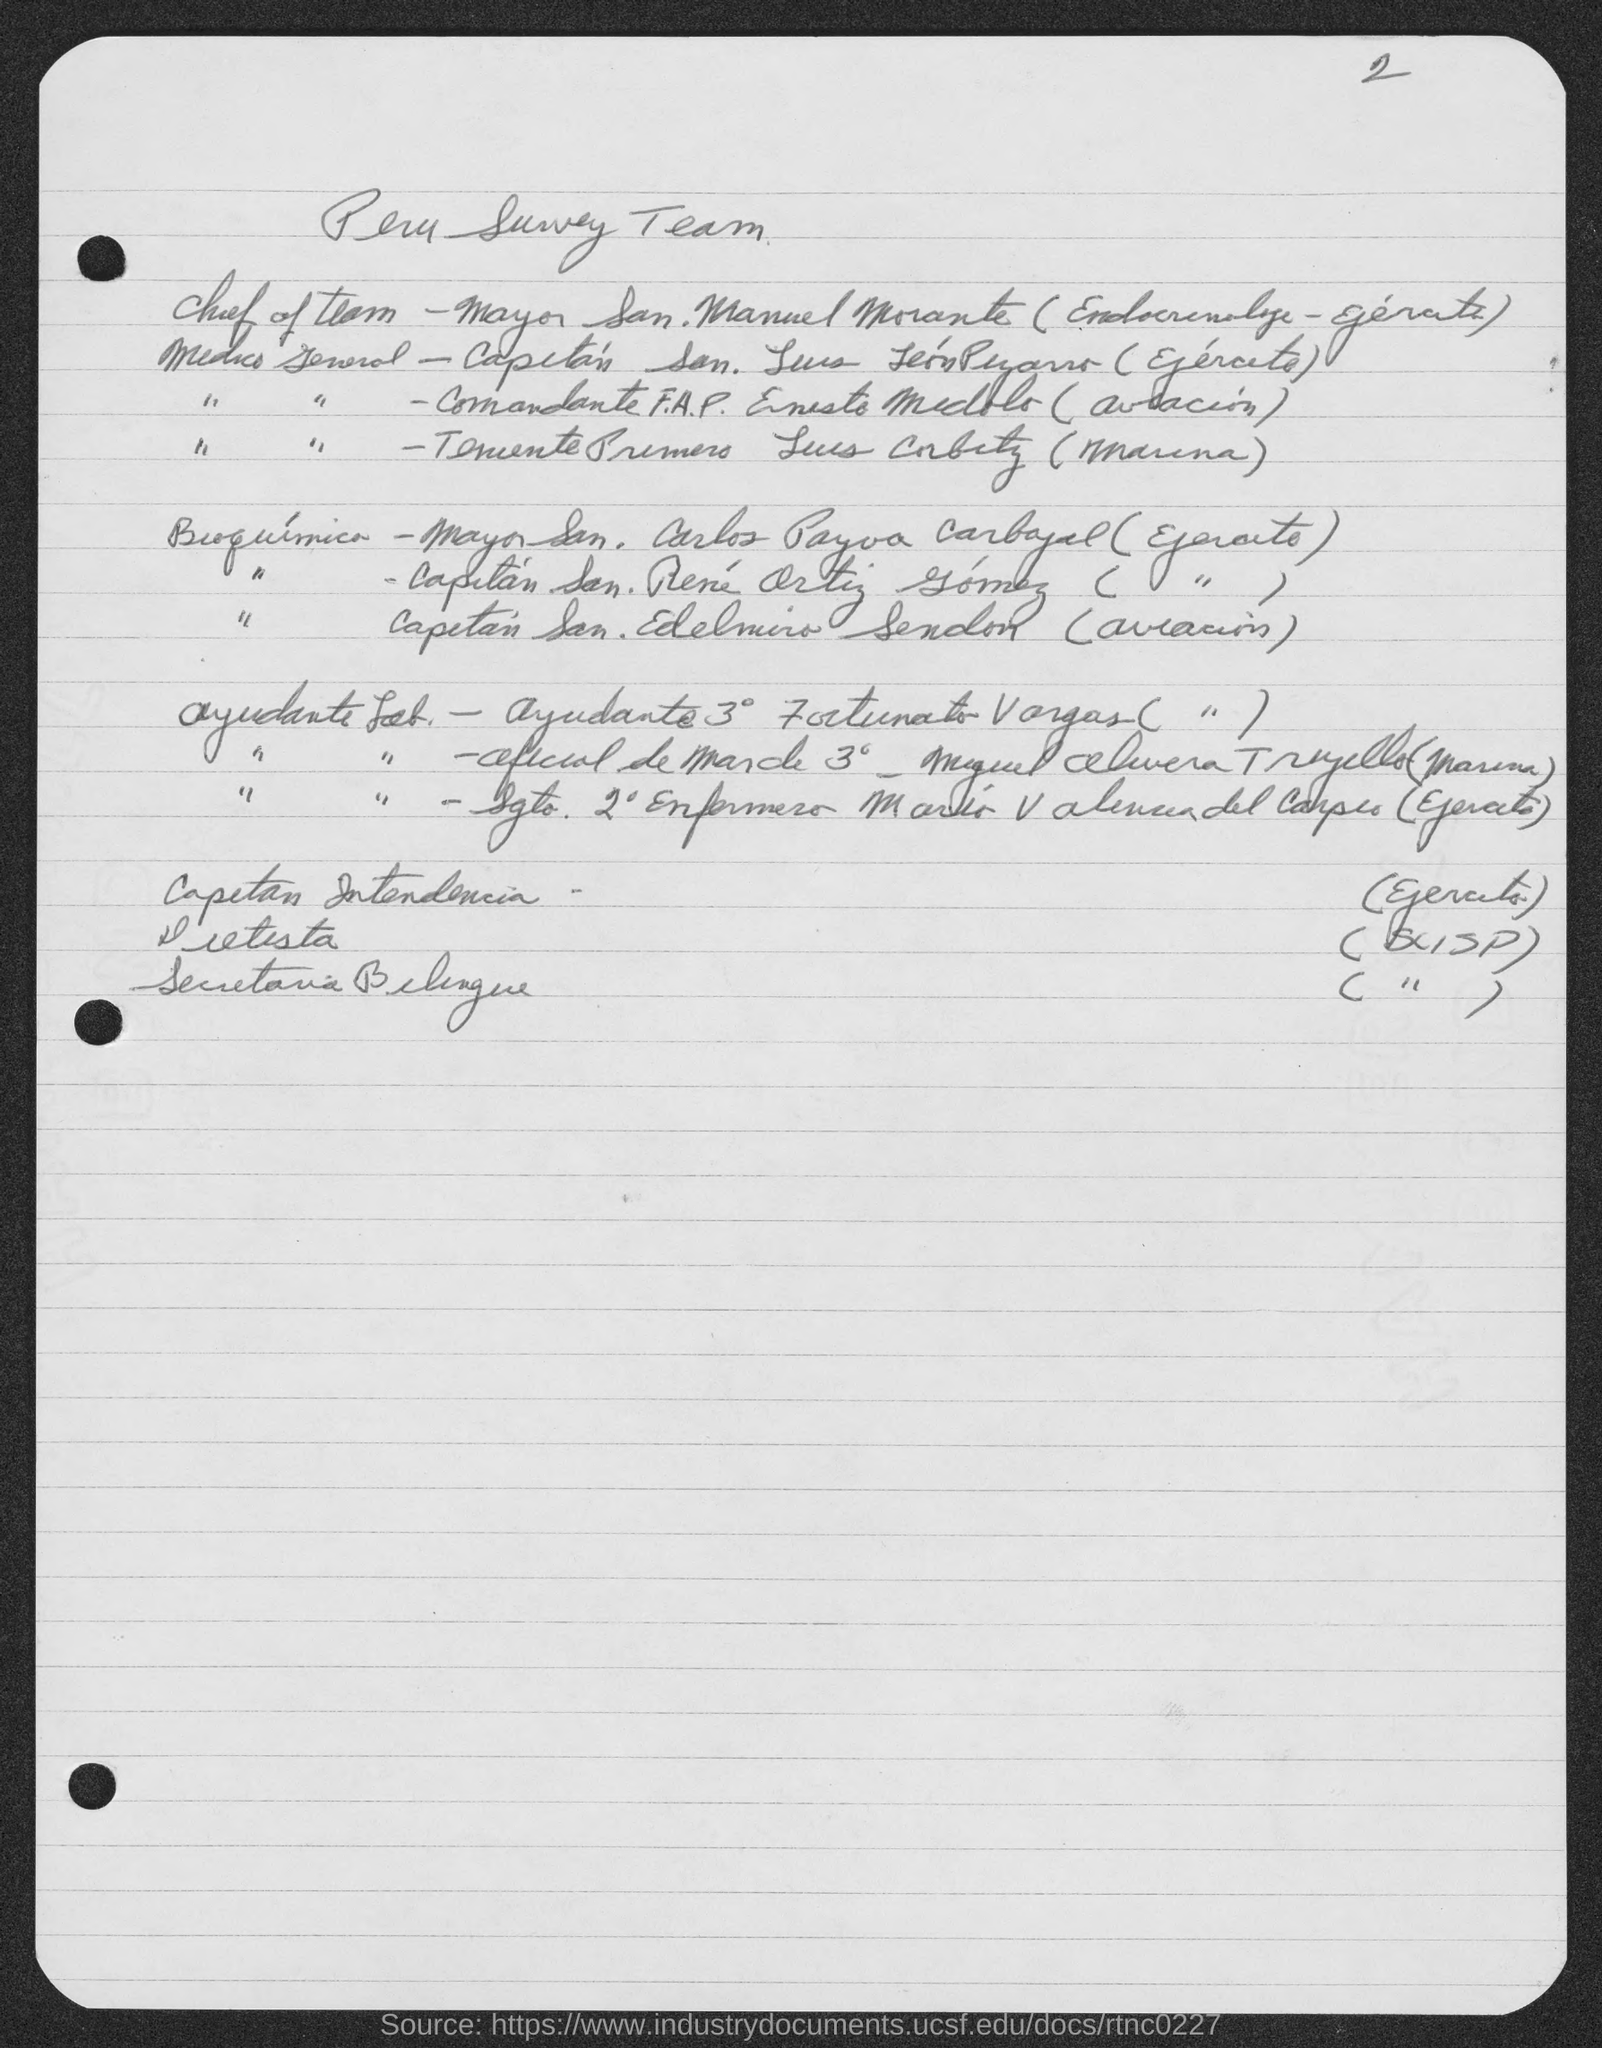What is the page number?
Your response must be concise. 2. 